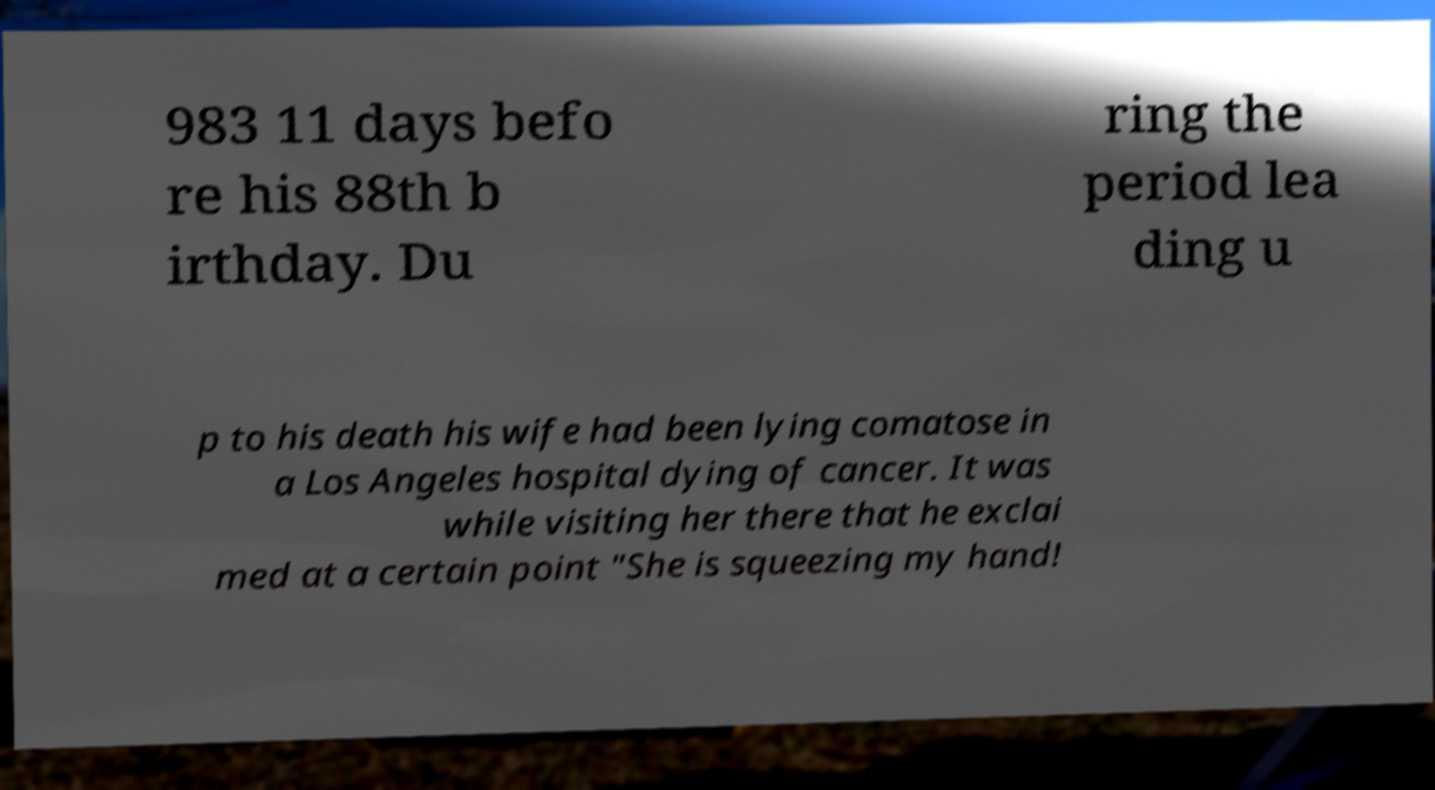Please identify and transcribe the text found in this image. 983 11 days befo re his 88th b irthday. Du ring the period lea ding u p to his death his wife had been lying comatose in a Los Angeles hospital dying of cancer. It was while visiting her there that he exclai med at a certain point "She is squeezing my hand! 